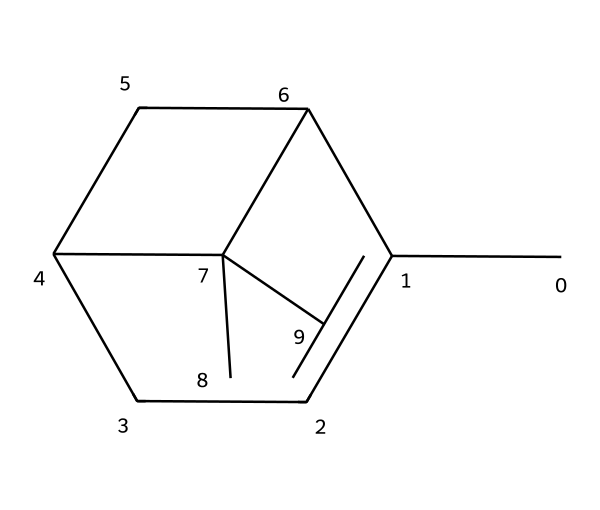What is the molecular formula of Pinene? By examining the structure represented by the SMILES string, we identify the number of carbon (C) and hydrogen (H) atoms. The molecule has 10 carbon atoms and 16 hydrogen atoms, giving the formula C10H16.
Answer: C10H16 How many rings are in the structure of Pinene? Looking closely at the molecular structure, we can see that there are two interconnected ring structures present (one cyclopentane and one cyclohexane), which indicates that this molecule is bicyclic in nature.
Answer: 2 Is Pinene a saturated or unsaturated compound? By analyzing the structure, we can observe the presence of double bonds between carbon atoms in the rings. The presence of these pi bonds suggests that the compound is unsaturated.
Answer: unsaturated What type of terpene is Pinene classified as? Pinene is specifically classified as a bicyclic monoterpene due to its two-ring structure and being derived from a 10-carbon skeleton of terpenes, typically categorized as monoterpenes.
Answer: monoterpene Which part of the molecule indicates the presence of a double bond? In the molecular structure, we see that there are carbon atoms that are bonded by less than three single bonds, forming a double bond between a pair of carbon atoms, which can be identified by the angles formed and the lack of hydrogen atoms bonded to these specific carbons.
Answer: double bond What kind of symmetry does Pinene exhibit? The molecule displays certain symmetrical properties due to its bicyclic structure and the nature of the carbon connectivity, where some dihedral angles about the rings can reflect symmetrical aspects, giving rise to various conformations.
Answer: symmetrical 